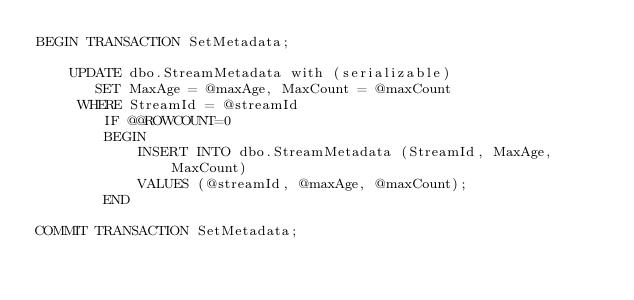Convert code to text. <code><loc_0><loc_0><loc_500><loc_500><_SQL_>BEGIN TRANSACTION SetMetadata;

    UPDATE dbo.StreamMetadata with (serializable)
       SET MaxAge = @maxAge, MaxCount = @maxCount
     WHERE StreamId = @streamId
        IF @@ROWCOUNT=0
        BEGIN
            INSERT INTO dbo.StreamMetadata (StreamId, MaxAge, MaxCount)
            VALUES (@streamId, @maxAge, @maxCount);
        END

COMMIT TRANSACTION SetMetadata;
</code> 